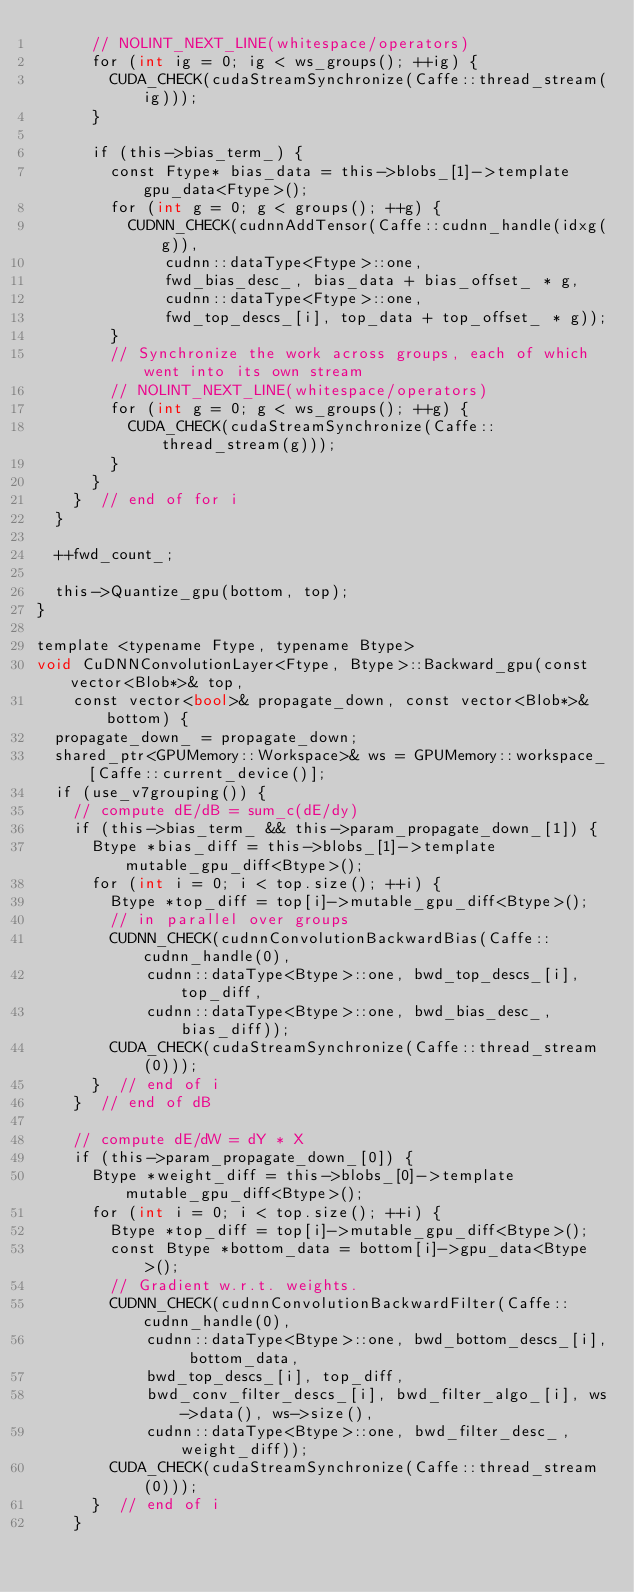<code> <loc_0><loc_0><loc_500><loc_500><_Cuda_>      // NOLINT_NEXT_LINE(whitespace/operators)
      for (int ig = 0; ig < ws_groups(); ++ig) {
        CUDA_CHECK(cudaStreamSynchronize(Caffe::thread_stream(ig)));
      }

      if (this->bias_term_) {
        const Ftype* bias_data = this->blobs_[1]->template gpu_data<Ftype>();
        for (int g = 0; g < groups(); ++g) {
          CUDNN_CHECK(cudnnAddTensor(Caffe::cudnn_handle(idxg(g)),
              cudnn::dataType<Ftype>::one,
              fwd_bias_desc_, bias_data + bias_offset_ * g,
              cudnn::dataType<Ftype>::one,
              fwd_top_descs_[i], top_data + top_offset_ * g));
        }
        // Synchronize the work across groups, each of which went into its own stream
        // NOLINT_NEXT_LINE(whitespace/operators)
        for (int g = 0; g < ws_groups(); ++g) {
          CUDA_CHECK(cudaStreamSynchronize(Caffe::thread_stream(g)));
        }
      }
    }  // end of for i
  }

  ++fwd_count_;
  
  this->Quantize_gpu(bottom, top);    
}

template <typename Ftype, typename Btype>
void CuDNNConvolutionLayer<Ftype, Btype>::Backward_gpu(const vector<Blob*>& top,
    const vector<bool>& propagate_down, const vector<Blob*>& bottom) {
  propagate_down_ = propagate_down;
  shared_ptr<GPUMemory::Workspace>& ws = GPUMemory::workspace_[Caffe::current_device()];
  if (use_v7grouping()) {
    // compute dE/dB = sum_c(dE/dy)
    if (this->bias_term_ && this->param_propagate_down_[1]) {
      Btype *bias_diff = this->blobs_[1]->template mutable_gpu_diff<Btype>();
      for (int i = 0; i < top.size(); ++i) {
        Btype *top_diff = top[i]->mutable_gpu_diff<Btype>();
        // in parallel over groups
        CUDNN_CHECK(cudnnConvolutionBackwardBias(Caffe::cudnn_handle(0),
            cudnn::dataType<Btype>::one, bwd_top_descs_[i], top_diff,
            cudnn::dataType<Btype>::one, bwd_bias_desc_, bias_diff));
        CUDA_CHECK(cudaStreamSynchronize(Caffe::thread_stream(0)));
      }  // end of i
    }  // end of dB

    // compute dE/dW = dY * X
    if (this->param_propagate_down_[0]) {
      Btype *weight_diff = this->blobs_[0]->template mutable_gpu_diff<Btype>();
      for (int i = 0; i < top.size(); ++i) {
        Btype *top_diff = top[i]->mutable_gpu_diff<Btype>();
        const Btype *bottom_data = bottom[i]->gpu_data<Btype>();
        // Gradient w.r.t. weights.
        CUDNN_CHECK(cudnnConvolutionBackwardFilter(Caffe::cudnn_handle(0),
            cudnn::dataType<Btype>::one, bwd_bottom_descs_[i], bottom_data,
            bwd_top_descs_[i], top_diff,
            bwd_conv_filter_descs_[i], bwd_filter_algo_[i], ws->data(), ws->size(),
            cudnn::dataType<Btype>::one, bwd_filter_desc_, weight_diff));
        CUDA_CHECK(cudaStreamSynchronize(Caffe::thread_stream(0)));
      }  // end of i
    }
</code> 